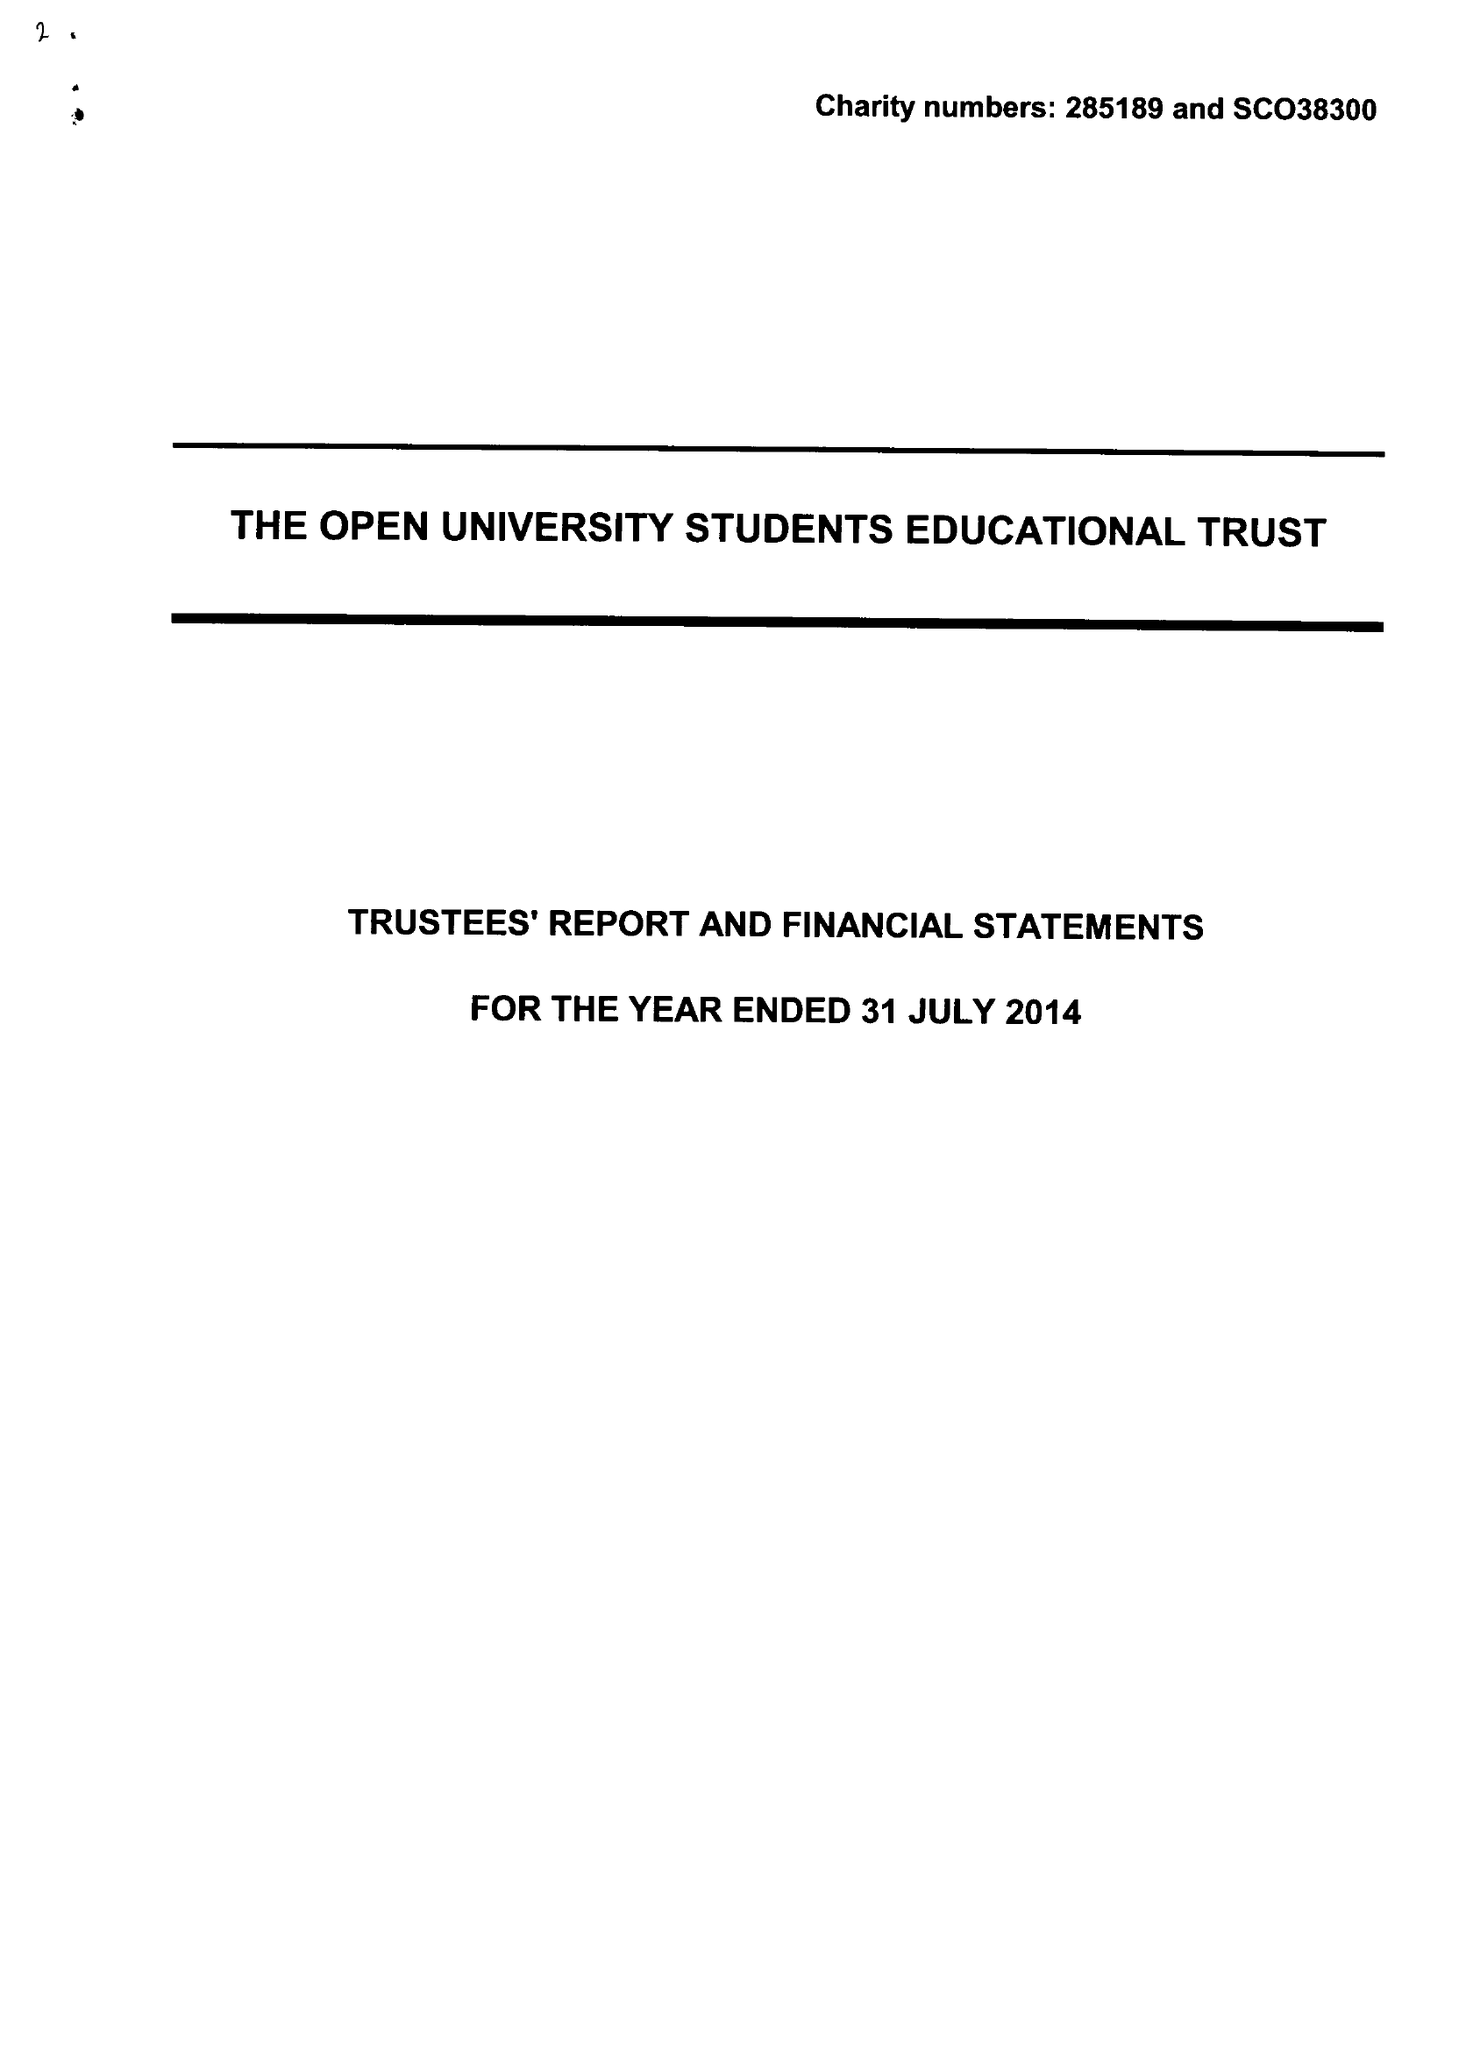What is the value for the spending_annually_in_british_pounds?
Answer the question using a single word or phrase. 119369.00 